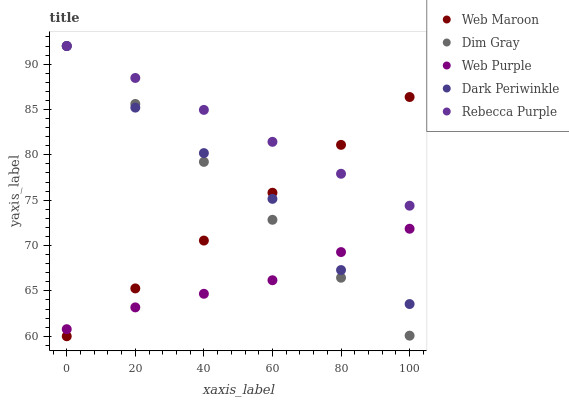Does Web Purple have the minimum area under the curve?
Answer yes or no. Yes. Does Rebecca Purple have the maximum area under the curve?
Answer yes or no. Yes. Does Dim Gray have the minimum area under the curve?
Answer yes or no. No. Does Dim Gray have the maximum area under the curve?
Answer yes or no. No. Is Rebecca Purple the smoothest?
Answer yes or no. Yes. Is Dark Periwinkle the roughest?
Answer yes or no. Yes. Is Dim Gray the smoothest?
Answer yes or no. No. Is Dim Gray the roughest?
Answer yes or no. No. Does Web Maroon have the lowest value?
Answer yes or no. Yes. Does Dim Gray have the lowest value?
Answer yes or no. No. Does Rebecca Purple have the highest value?
Answer yes or no. Yes. Does Web Maroon have the highest value?
Answer yes or no. No. Is Web Purple less than Rebecca Purple?
Answer yes or no. Yes. Is Rebecca Purple greater than Web Purple?
Answer yes or no. Yes. Does Web Maroon intersect Dark Periwinkle?
Answer yes or no. Yes. Is Web Maroon less than Dark Periwinkle?
Answer yes or no. No. Is Web Maroon greater than Dark Periwinkle?
Answer yes or no. No. Does Web Purple intersect Rebecca Purple?
Answer yes or no. No. 